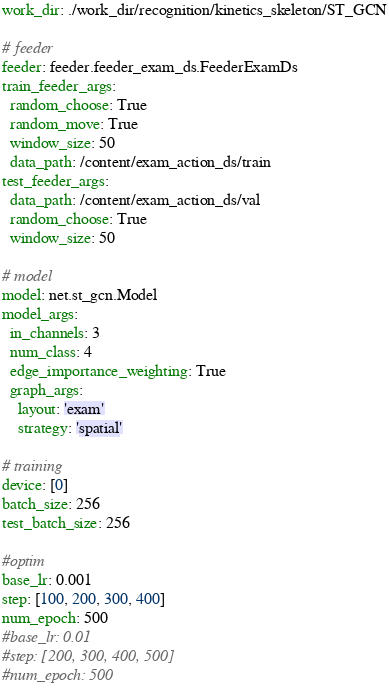<code> <loc_0><loc_0><loc_500><loc_500><_YAML_>work_dir: ./work_dir/recognition/kinetics_skeleton/ST_GCN

# feeder
feeder: feeder.feeder_exam_ds.FeederExamDs
train_feeder_args:
  random_choose: True
  random_move: True
  window_size: 50 
  data_path: /content/exam_action_ds/train
test_feeder_args:
  data_path: /content/exam_action_ds/val
  random_choose: True
  window_size: 50

# model
model: net.st_gcn.Model
model_args:
  in_channels: 3
  num_class: 4
  edge_importance_weighting: True
  graph_args:
    layout: 'exam'
    strategy: 'spatial'

# training
device: [0]
batch_size: 256 
test_batch_size: 256

#optim
base_lr: 0.001
step: [100, 200, 300, 400]
num_epoch: 500
#base_lr: 0.01
#step: [200, 300, 400, 500]
#num_epoch: 500



</code> 